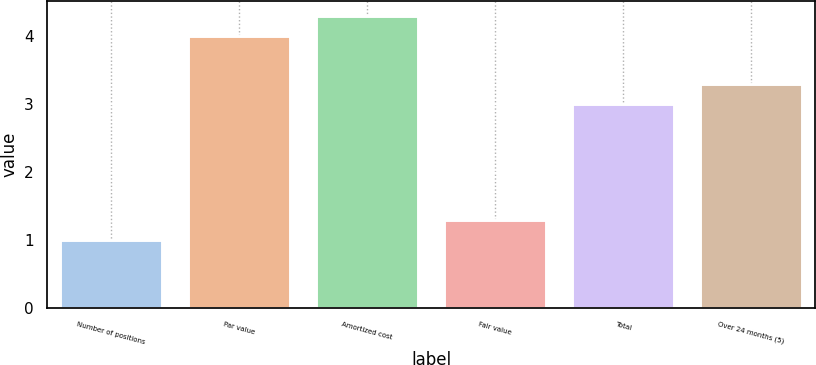Convert chart. <chart><loc_0><loc_0><loc_500><loc_500><bar_chart><fcel>Number of positions<fcel>Par value<fcel>Amortized cost<fcel>Fair value<fcel>Total<fcel>Over 24 months (5)<nl><fcel>1<fcel>4<fcel>4.3<fcel>1.3<fcel>3<fcel>3.3<nl></chart> 